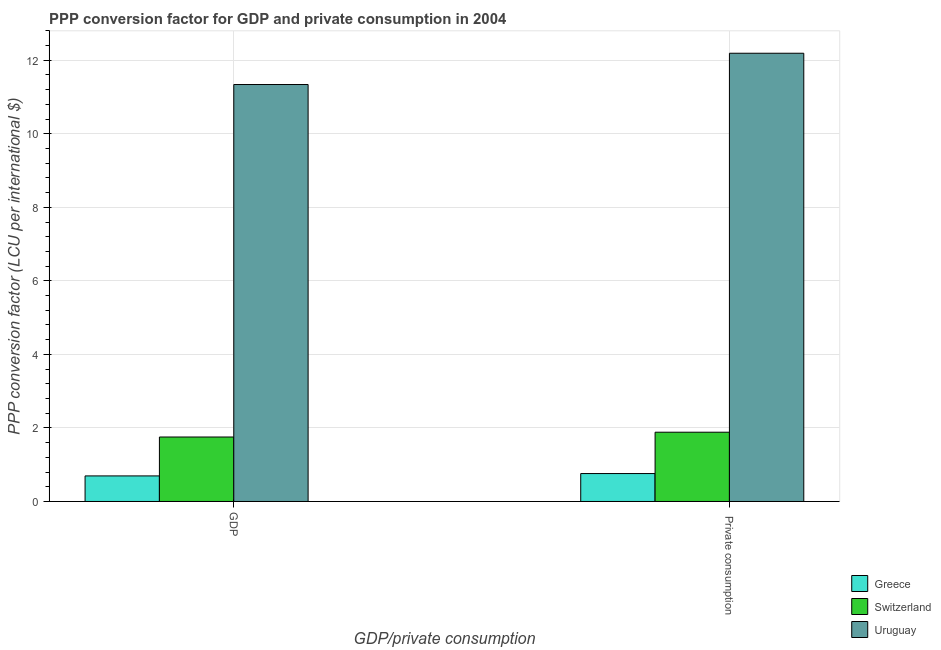How many groups of bars are there?
Your response must be concise. 2. Are the number of bars per tick equal to the number of legend labels?
Make the answer very short. Yes. Are the number of bars on each tick of the X-axis equal?
Ensure brevity in your answer.  Yes. How many bars are there on the 2nd tick from the right?
Make the answer very short. 3. What is the label of the 2nd group of bars from the left?
Make the answer very short.  Private consumption. What is the ppp conversion factor for private consumption in Switzerland?
Offer a very short reply. 1.88. Across all countries, what is the maximum ppp conversion factor for private consumption?
Keep it short and to the point. 12.19. Across all countries, what is the minimum ppp conversion factor for private consumption?
Keep it short and to the point. 0.76. In which country was the ppp conversion factor for gdp maximum?
Your answer should be very brief. Uruguay. What is the total ppp conversion factor for private consumption in the graph?
Give a very brief answer. 14.83. What is the difference between the ppp conversion factor for private consumption in Uruguay and that in Greece?
Ensure brevity in your answer.  11.43. What is the difference between the ppp conversion factor for private consumption in Uruguay and the ppp conversion factor for gdp in Switzerland?
Give a very brief answer. 10.44. What is the average ppp conversion factor for private consumption per country?
Offer a very short reply. 4.94. What is the difference between the ppp conversion factor for private consumption and ppp conversion factor for gdp in Switzerland?
Your answer should be compact. 0.13. What is the ratio of the ppp conversion factor for private consumption in Switzerland to that in Uruguay?
Make the answer very short. 0.15. What does the 1st bar from the left in GDP represents?
Your answer should be compact. Greece. What does the 3rd bar from the right in GDP represents?
Keep it short and to the point. Greece. How many bars are there?
Provide a short and direct response. 6. How many countries are there in the graph?
Provide a succinct answer. 3. What is the difference between two consecutive major ticks on the Y-axis?
Your answer should be compact. 2. Does the graph contain any zero values?
Your answer should be very brief. No. What is the title of the graph?
Your response must be concise. PPP conversion factor for GDP and private consumption in 2004. What is the label or title of the X-axis?
Your answer should be compact. GDP/private consumption. What is the label or title of the Y-axis?
Provide a succinct answer. PPP conversion factor (LCU per international $). What is the PPP conversion factor (LCU per international $) of Greece in GDP?
Your response must be concise. 0.7. What is the PPP conversion factor (LCU per international $) in Switzerland in GDP?
Provide a short and direct response. 1.75. What is the PPP conversion factor (LCU per international $) in Uruguay in GDP?
Offer a terse response. 11.34. What is the PPP conversion factor (LCU per international $) in Greece in  Private consumption?
Your answer should be compact. 0.76. What is the PPP conversion factor (LCU per international $) in Switzerland in  Private consumption?
Keep it short and to the point. 1.88. What is the PPP conversion factor (LCU per international $) of Uruguay in  Private consumption?
Your response must be concise. 12.19. Across all GDP/private consumption, what is the maximum PPP conversion factor (LCU per international $) of Greece?
Your answer should be compact. 0.76. Across all GDP/private consumption, what is the maximum PPP conversion factor (LCU per international $) in Switzerland?
Provide a short and direct response. 1.88. Across all GDP/private consumption, what is the maximum PPP conversion factor (LCU per international $) of Uruguay?
Give a very brief answer. 12.19. Across all GDP/private consumption, what is the minimum PPP conversion factor (LCU per international $) in Greece?
Provide a short and direct response. 0.7. Across all GDP/private consumption, what is the minimum PPP conversion factor (LCU per international $) in Switzerland?
Give a very brief answer. 1.75. Across all GDP/private consumption, what is the minimum PPP conversion factor (LCU per international $) of Uruguay?
Give a very brief answer. 11.34. What is the total PPP conversion factor (LCU per international $) of Greece in the graph?
Provide a succinct answer. 1.45. What is the total PPP conversion factor (LCU per international $) in Switzerland in the graph?
Give a very brief answer. 3.64. What is the total PPP conversion factor (LCU per international $) of Uruguay in the graph?
Your answer should be compact. 23.53. What is the difference between the PPP conversion factor (LCU per international $) of Greece in GDP and that in  Private consumption?
Keep it short and to the point. -0.06. What is the difference between the PPP conversion factor (LCU per international $) of Switzerland in GDP and that in  Private consumption?
Provide a short and direct response. -0.13. What is the difference between the PPP conversion factor (LCU per international $) in Uruguay in GDP and that in  Private consumption?
Ensure brevity in your answer.  -0.85. What is the difference between the PPP conversion factor (LCU per international $) in Greece in GDP and the PPP conversion factor (LCU per international $) in Switzerland in  Private consumption?
Ensure brevity in your answer.  -1.19. What is the difference between the PPP conversion factor (LCU per international $) of Greece in GDP and the PPP conversion factor (LCU per international $) of Uruguay in  Private consumption?
Make the answer very short. -11.5. What is the difference between the PPP conversion factor (LCU per international $) of Switzerland in GDP and the PPP conversion factor (LCU per international $) of Uruguay in  Private consumption?
Your answer should be very brief. -10.44. What is the average PPP conversion factor (LCU per international $) of Greece per GDP/private consumption?
Offer a terse response. 0.73. What is the average PPP conversion factor (LCU per international $) of Switzerland per GDP/private consumption?
Offer a very short reply. 1.82. What is the average PPP conversion factor (LCU per international $) in Uruguay per GDP/private consumption?
Your answer should be compact. 11.77. What is the difference between the PPP conversion factor (LCU per international $) of Greece and PPP conversion factor (LCU per international $) of Switzerland in GDP?
Provide a succinct answer. -1.06. What is the difference between the PPP conversion factor (LCU per international $) in Greece and PPP conversion factor (LCU per international $) in Uruguay in GDP?
Your response must be concise. -10.65. What is the difference between the PPP conversion factor (LCU per international $) of Switzerland and PPP conversion factor (LCU per international $) of Uruguay in GDP?
Offer a very short reply. -9.59. What is the difference between the PPP conversion factor (LCU per international $) in Greece and PPP conversion factor (LCU per international $) in Switzerland in  Private consumption?
Your answer should be compact. -1.12. What is the difference between the PPP conversion factor (LCU per international $) of Greece and PPP conversion factor (LCU per international $) of Uruguay in  Private consumption?
Ensure brevity in your answer.  -11.43. What is the difference between the PPP conversion factor (LCU per international $) in Switzerland and PPP conversion factor (LCU per international $) in Uruguay in  Private consumption?
Provide a short and direct response. -10.31. What is the ratio of the PPP conversion factor (LCU per international $) in Greece in GDP to that in  Private consumption?
Your answer should be compact. 0.92. What is the ratio of the PPP conversion factor (LCU per international $) in Switzerland in GDP to that in  Private consumption?
Your answer should be compact. 0.93. What is the ratio of the PPP conversion factor (LCU per international $) in Uruguay in GDP to that in  Private consumption?
Your answer should be compact. 0.93. What is the difference between the highest and the second highest PPP conversion factor (LCU per international $) of Greece?
Make the answer very short. 0.06. What is the difference between the highest and the second highest PPP conversion factor (LCU per international $) in Switzerland?
Ensure brevity in your answer.  0.13. What is the difference between the highest and the second highest PPP conversion factor (LCU per international $) of Uruguay?
Your answer should be very brief. 0.85. What is the difference between the highest and the lowest PPP conversion factor (LCU per international $) of Greece?
Your response must be concise. 0.06. What is the difference between the highest and the lowest PPP conversion factor (LCU per international $) of Switzerland?
Make the answer very short. 0.13. What is the difference between the highest and the lowest PPP conversion factor (LCU per international $) of Uruguay?
Your answer should be compact. 0.85. 